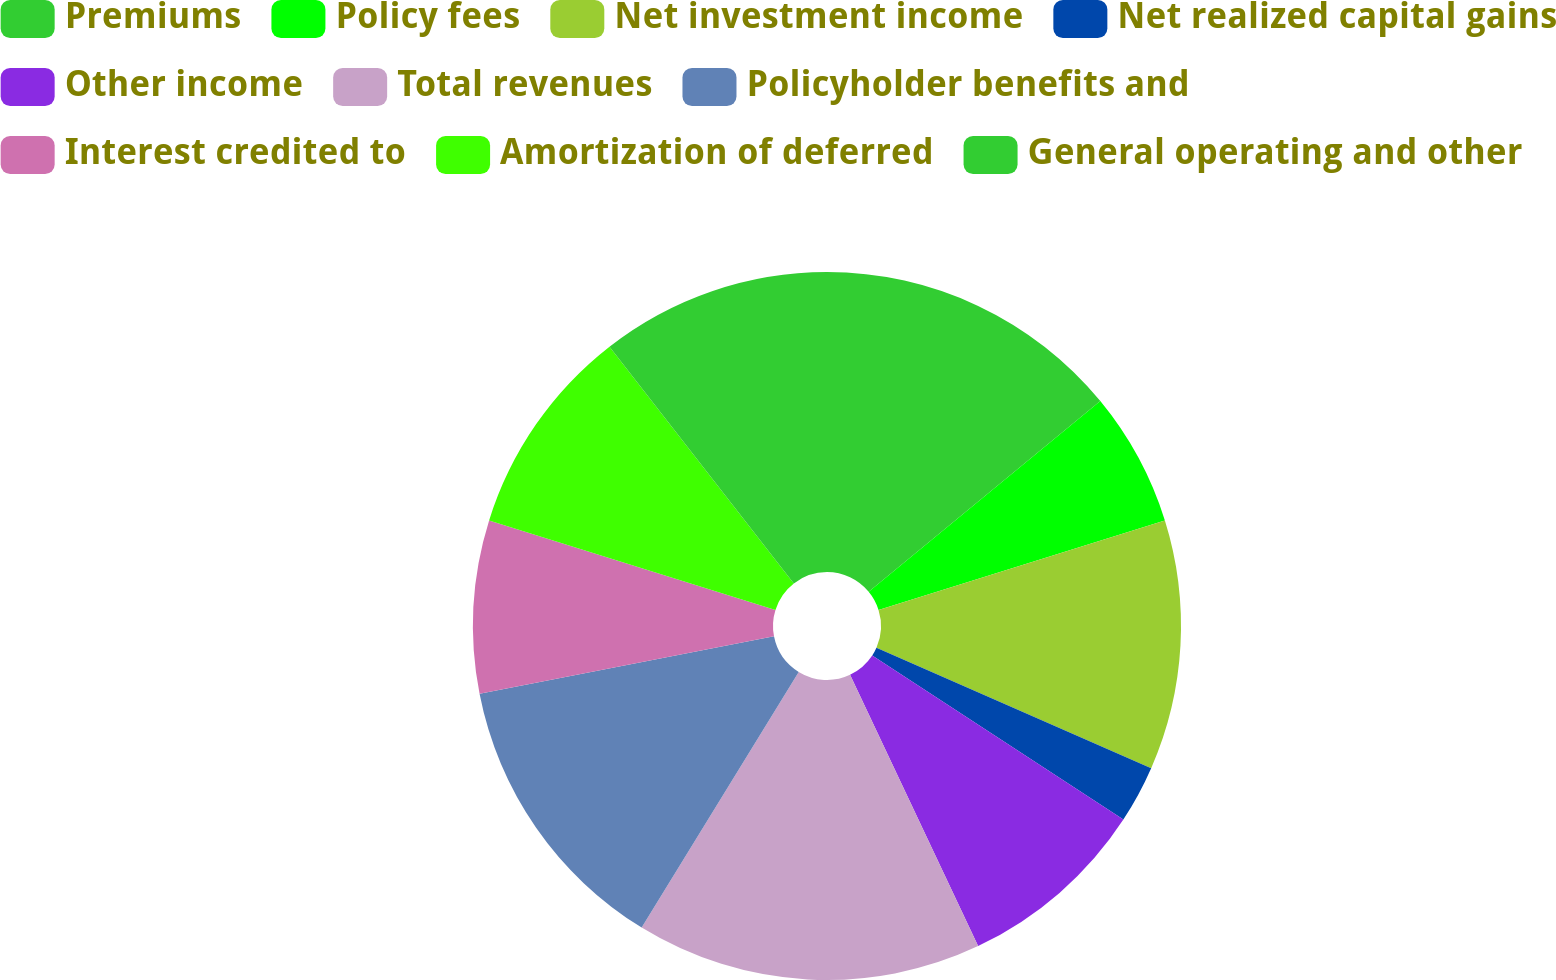Convert chart to OTSL. <chart><loc_0><loc_0><loc_500><loc_500><pie_chart><fcel>Premiums<fcel>Policy fees<fcel>Net investment income<fcel>Net realized capital gains<fcel>Other income<fcel>Total revenues<fcel>Policyholder benefits and<fcel>Interest credited to<fcel>Amortization of deferred<fcel>General operating and other<nl><fcel>14.04%<fcel>6.14%<fcel>11.4%<fcel>2.63%<fcel>8.77%<fcel>15.79%<fcel>13.16%<fcel>7.89%<fcel>9.65%<fcel>10.53%<nl></chart> 